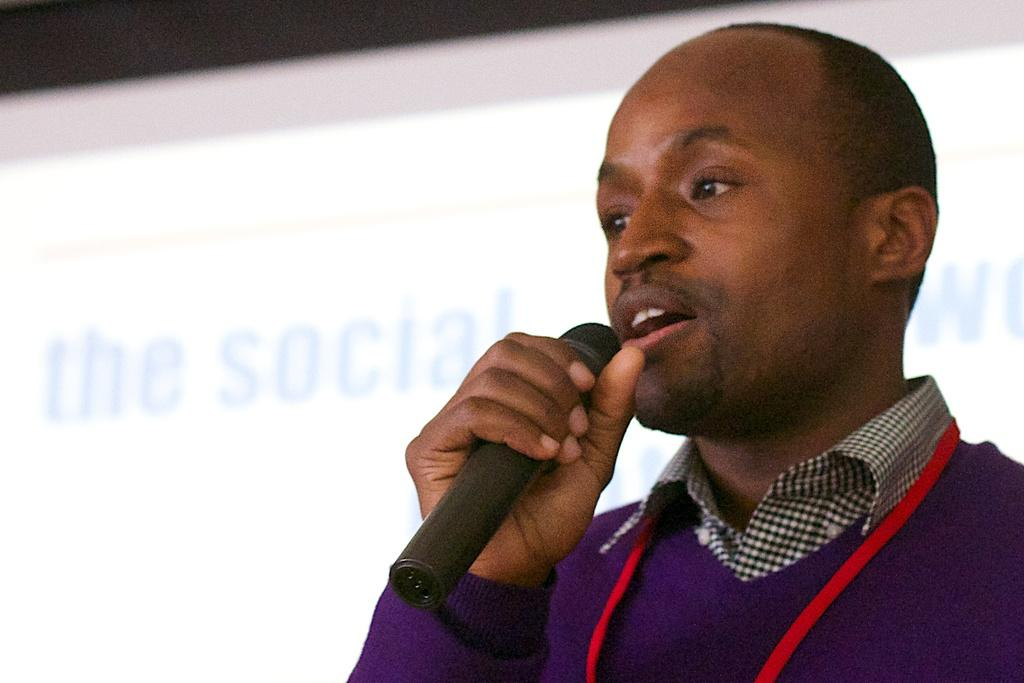Who or what is the main subject in the image? There is a person in the image. What is the person holding in the image? The person is holding a microphone. What is the person doing with the microphone? The person is talking. What can be seen in the background of the image? There is a screen visible in the background of the image. What type of stocking is the person wearing in the image? There is no information about the person's clothing, including stockings, in the image. Can you tell me how many tubs are visible in the image? There are no tubs present in the image. 